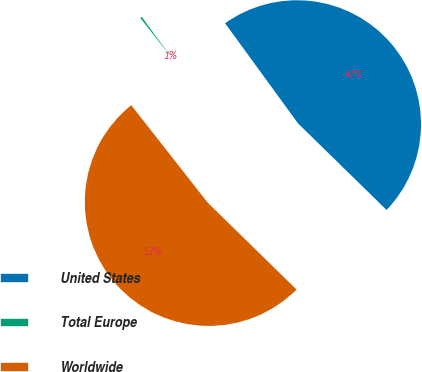Convert chart to OTSL. <chart><loc_0><loc_0><loc_500><loc_500><pie_chart><fcel>United States<fcel>Total Europe<fcel>Worldwide<nl><fcel>47.34%<fcel>0.57%<fcel>52.09%<nl></chart> 